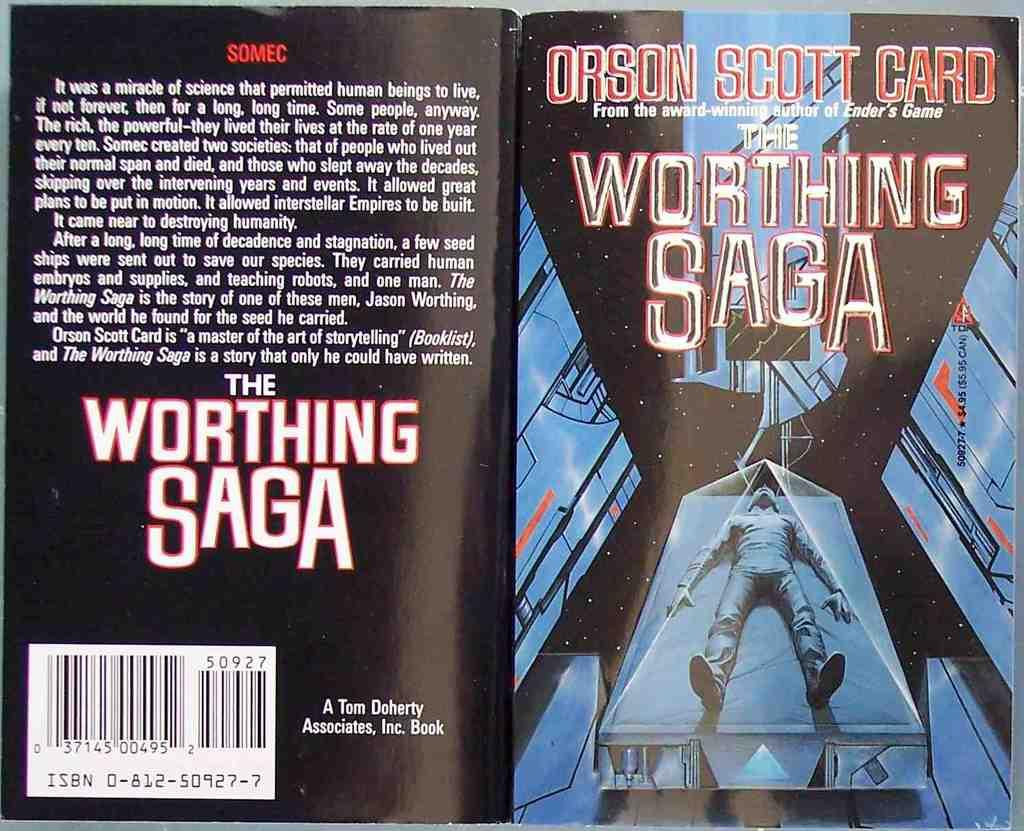<image>
Offer a succinct explanation of the picture presented. Book cover showing a man laying down and the name "The Worthing Saga". 